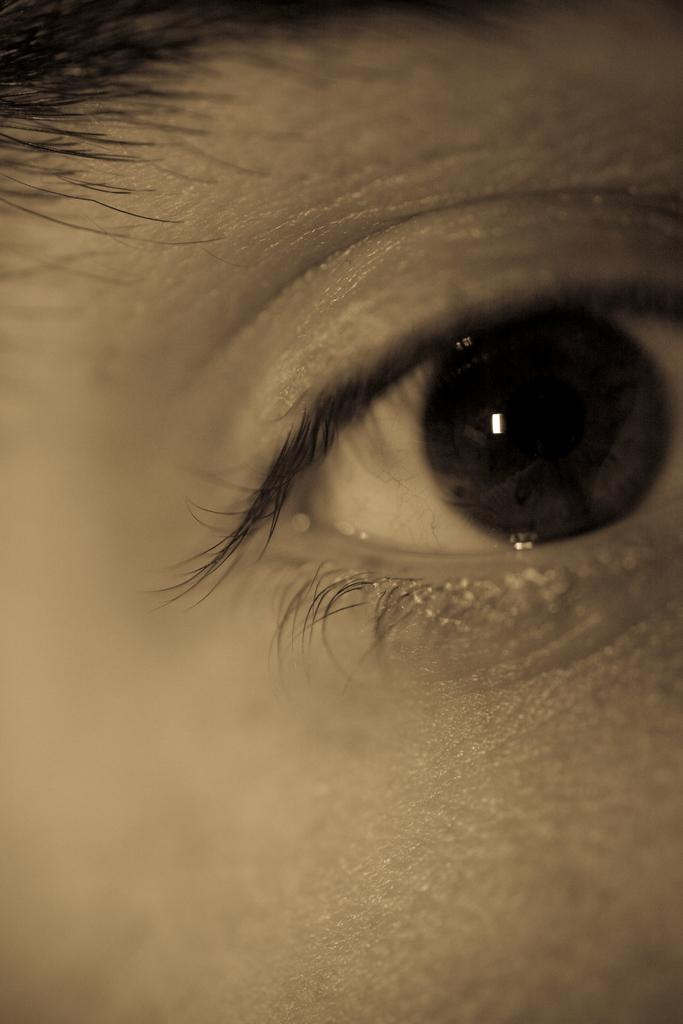What is the main subject of the image? The main subject of the image is the eye of a person. Can you describe the eye in the image? The eye appears to be a close-up view, showing details such as the iris and eyelashes. How many chairs are visible in the image? There are no chairs present in the image; it only features the eye of a person. What type of patch is sewn onto the eye in the image? There is no patch present on the eye in the image; it is a natural, unaltered eye. 